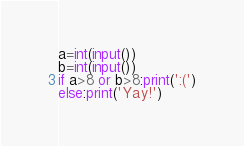Convert code to text. <code><loc_0><loc_0><loc_500><loc_500><_Python_>a=int(input())
b=int(input())
if a>8 or b>8:print(':(')
else:print('Yay!')</code> 